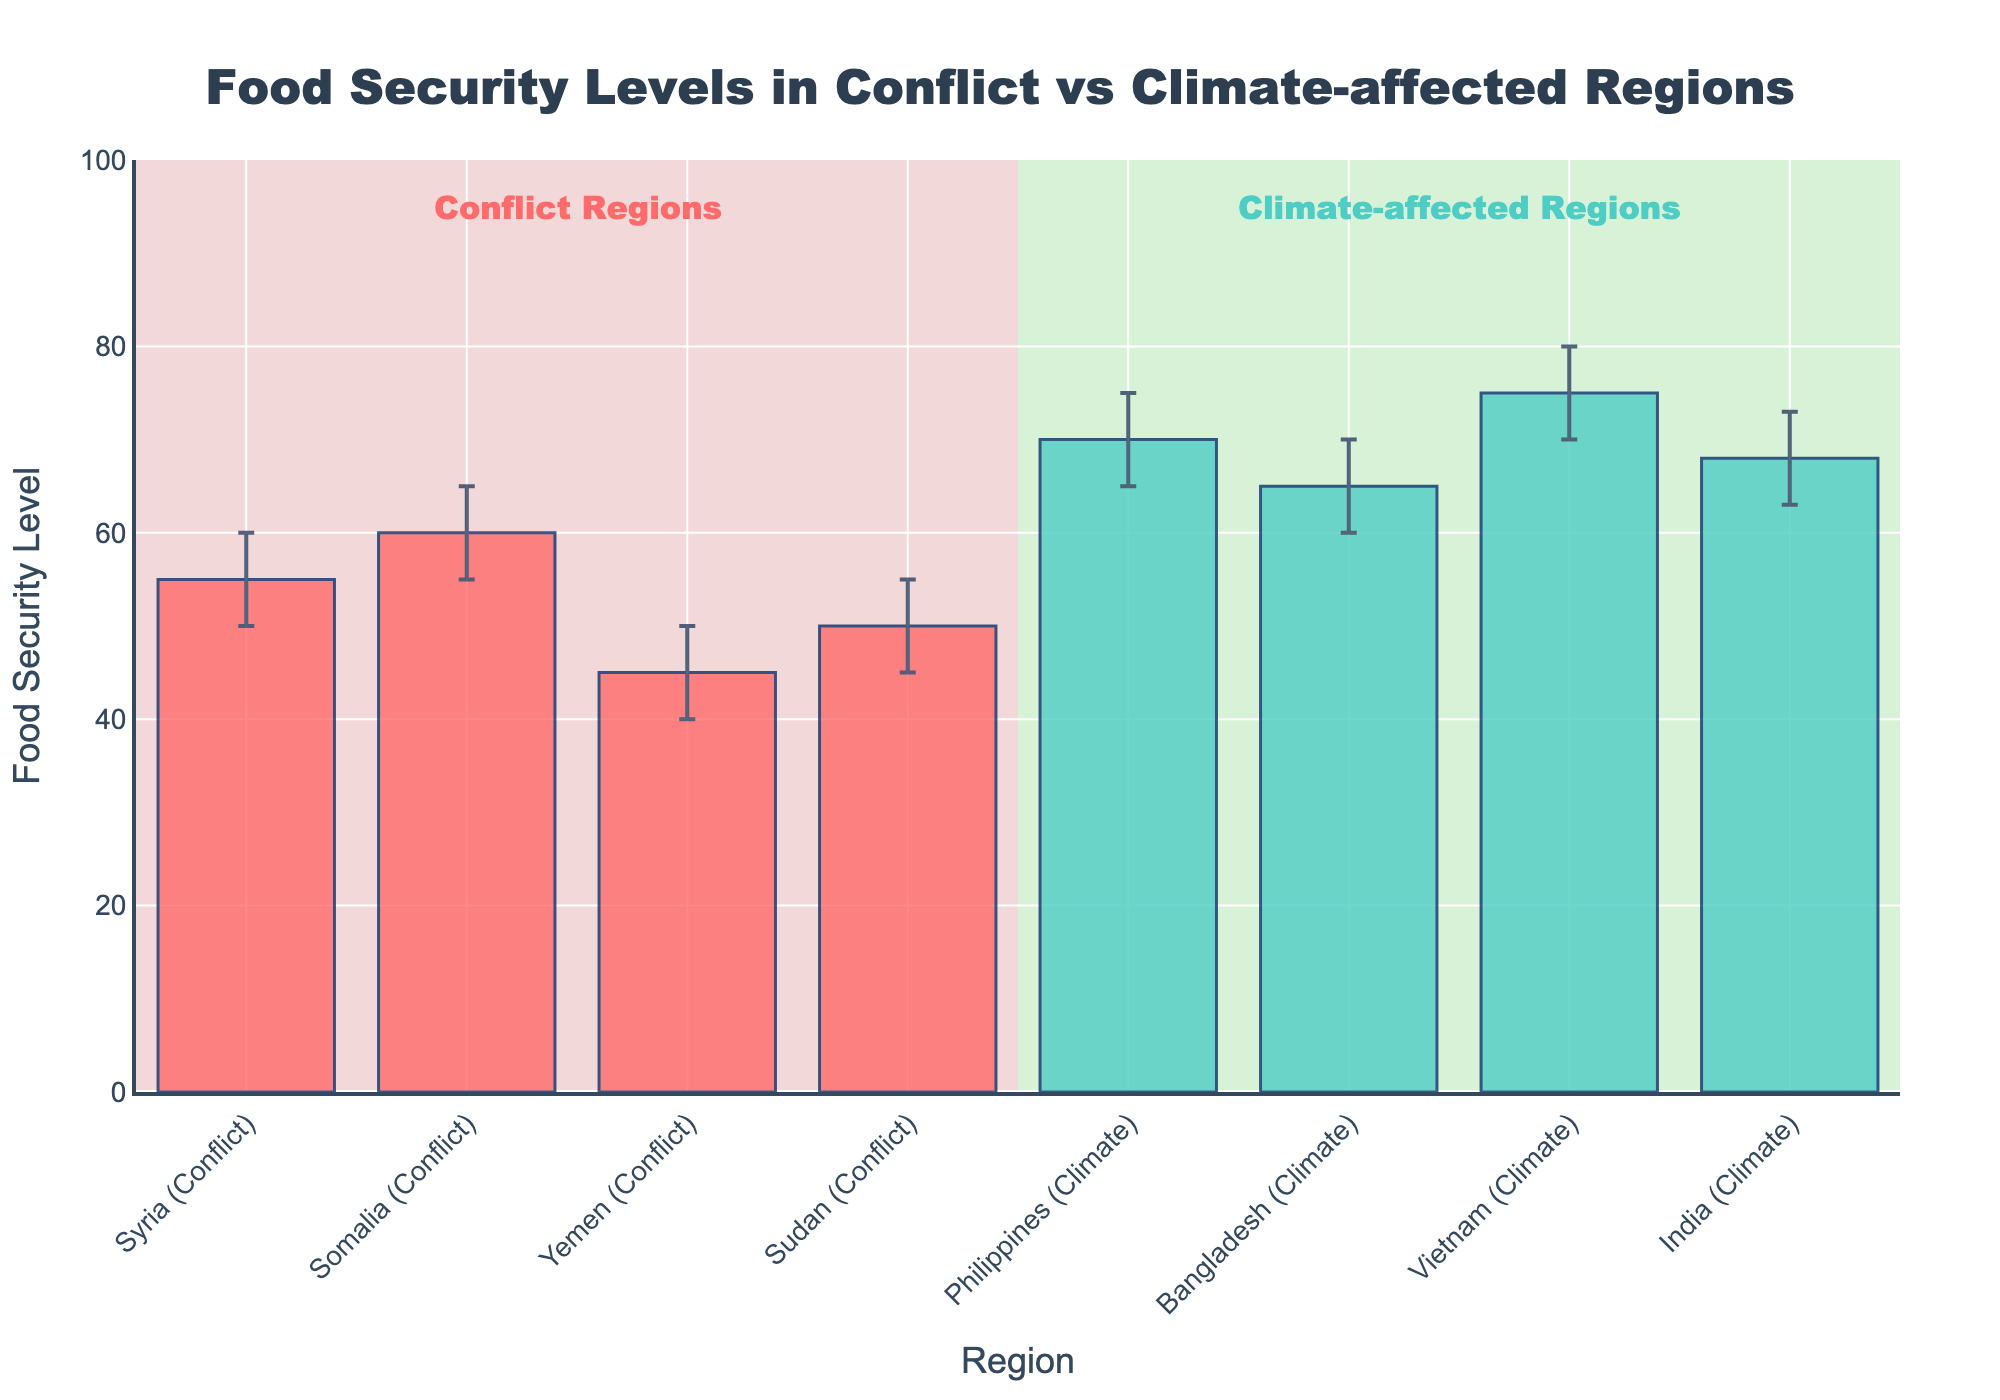What is the title of the figure? The title is displayed at the top center of the figure. It reads "Food Security Levels in Conflict vs Climate-affected Regions"
Answer: Food Security Levels in Conflict vs Climate-affected Regions Which region has the highest food security level? To determine the highest food security level, compare the heights of all the bars. The bar for Vietnam has the highest value.
Answer: Vietnam What is the food security level for Yemen? Look for the bar labeled 'Yemen (Conflict)' and read the value on the y-axis at the top of the bar. It is at 45.
Answer: 45 What is the difference in food security levels between Syria and India? Subtract the food security level for Syria (55) from that of India (68). 68 - 55 = 13
Answer: 13 Which has a larger confidence interval, Somalia or Bangladesh? Check the length of the error bars for both regions. Somalia's ranges from 55 to 65, making it 10 units long. Bangladesh's ranges from 60 to 70, also 10 units long. Both are equal.
Answer: Both are equal How many regions experiencing conflict are shown in the figure? Regions experiencing conflict are annotated in red and lie within one rectangle. Count the bars under 'Conflict Regions'. There are four: Syria, Somalia, Yemen, and Sudan.
Answer: 4 What is the average food security level of the climate-affected regions? Add the food security levels of all climate-affected regions and divide by their count. (70 + 65 + 75 + 68)/4 = 69.5
Answer: 69.5 Which region has the smallest confidence interval, and what are its bounds? Determine the length of the error bars visually and compare. Regions like Yemen and India have smaller bars. Yemen spans from 40 to 50; India spans from 63 to 73. Yemen's interval (10 units) is smaller. So, Yemen has the smallest confidence interval from 40 to 50.
Answer: Yemen, 40 to 50 Are the confidence intervals for Sudan and the Philippines overlapping? Sudan's interval is from 45 to 55, and the Philippines' interval is from 65 to 75. Since these intervals do not overlap, the answer is no.
Answer: No What is the total count of regions in the figure? Count all bars on the x-axis, both for conflict and climate-affected regions. There are eight bars in total.
Answer: 8 